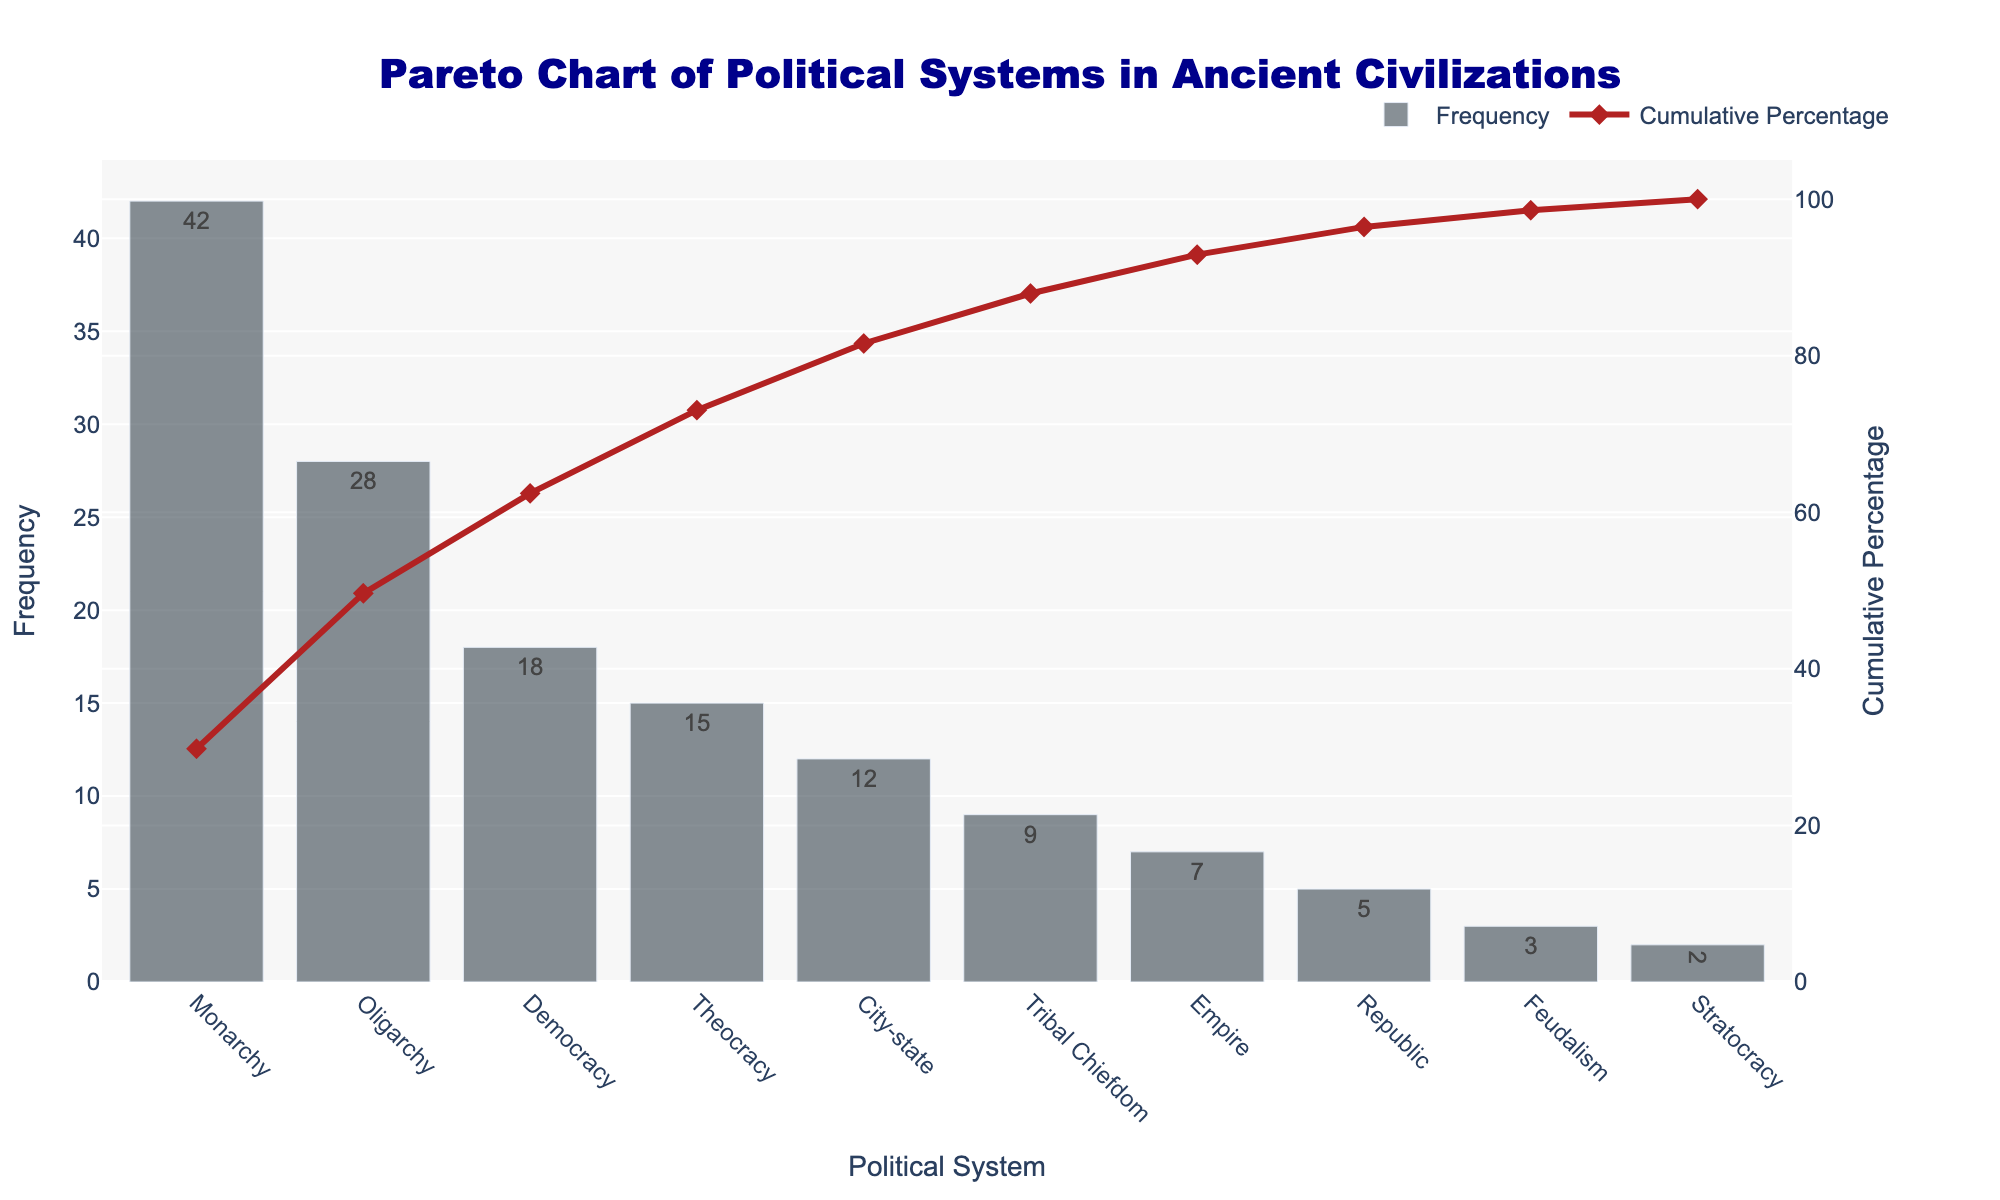What is the title of the chart? The title of the chart is located at the top center of the figure.
Answer: Pareto Chart of Political Systems in Ancient Civilizations Which political system has the highest frequency? The political system with the highest frequency is represented by the tallest bar.
Answer: Monarchy How many political systems have a frequency lower than 10? From the bars, we can see that the frequencies lower than 10 are for 'Tribal Chiefdom', 'Empire', 'Republic', 'Feudalism', and 'Stratocracy'. Counting these gives us five.
Answer: 5 What is the cumulative percentage for 'Oligarchy'? The cumulative percentage line for 'Oligarchy' intersects the y-axis. Trace this point horizontally to find the percentage value.
Answer: 65% Compare the frequencies of 'Democracy' and 'Republic'. Which one is higher, and by how much? 'Democracy' has a frequency of 18, whereas 'Republic' has a frequency of 5. Subtracting 5 from 18 gives us the difference.
Answer: Democracy by 13 What political systems contribute to 85% of the cumulative percentage? Refer to the cumulative percentage line and identify the political systems before it exceeds 85%. The systems are 'Monarchy', 'Oligarchy', 'Democracy', and 'Theocracy'.
Answer: Monarchy, Oligarchy, Democracy, and Theocracy What's the cumulative percentage of the top three political systems combined? Add the cumulative percentage values of 'Monarchy', 'Oligarchy', and 'Democracy': 42% + 65% - 42% (to avoid double-counting 'Oligarchy') + 18% = 85%.
Answer: 85% Which political system has the lowest frequency, and what is its frequency? The political system with the lowest frequency is represented by the shortest bar.
Answer: Stratocracy, with 2 What is the frequency difference between 'City-state' and 'Empire'? 'City-state' has a frequency of 12, and 'Empire' has a frequency of 7. Subtract 7 from 12.
Answer: 5 What is the range of the y-axis used for cumulative percentage? Check the scale on the secondary y-axis to determine the range.
Answer: 0 to 105 